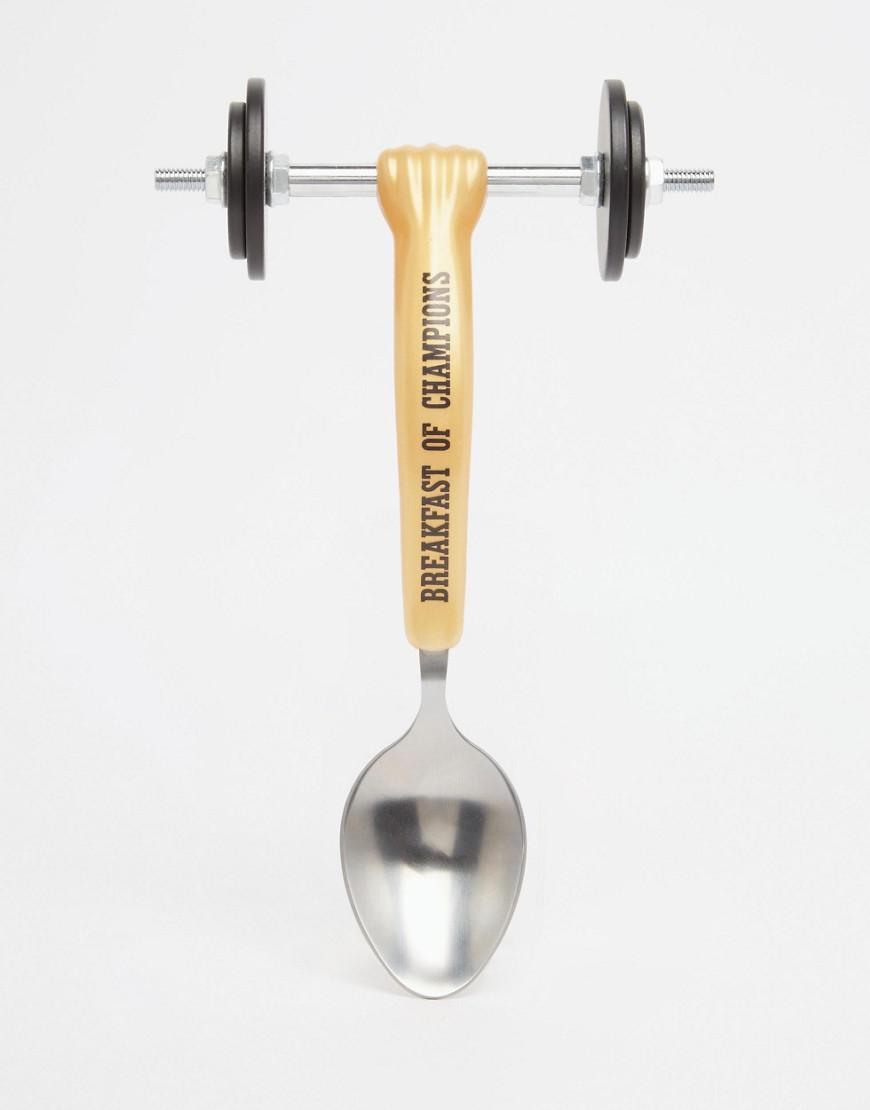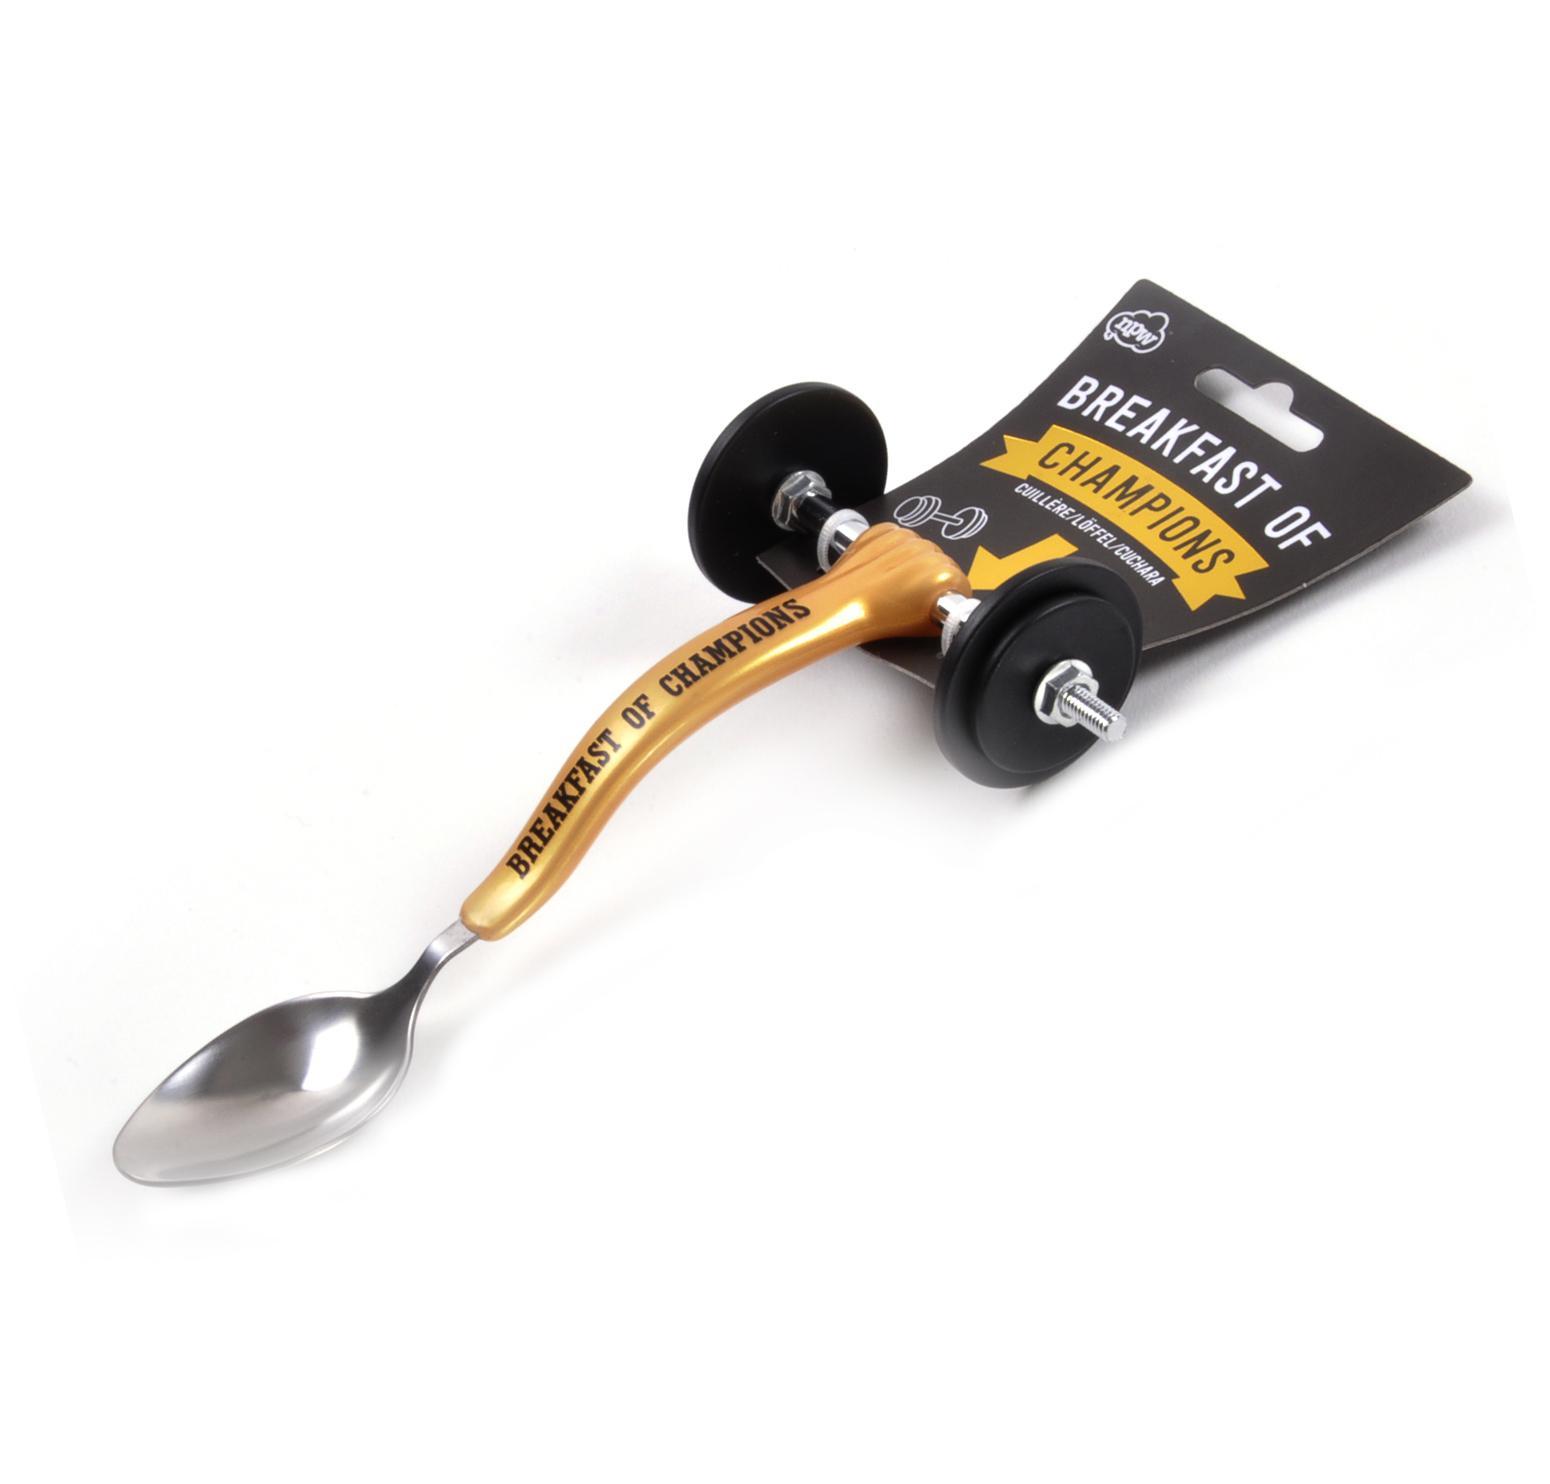The first image is the image on the left, the second image is the image on the right. Given the left and right images, does the statement "there is a hand in one of the images" hold true? Answer yes or no. No. The first image is the image on the left, the second image is the image on the right. Assess this claim about the two images: "In one image, a fancy spoon with wheels is held in a hand.". Correct or not? Answer yes or no. No. 